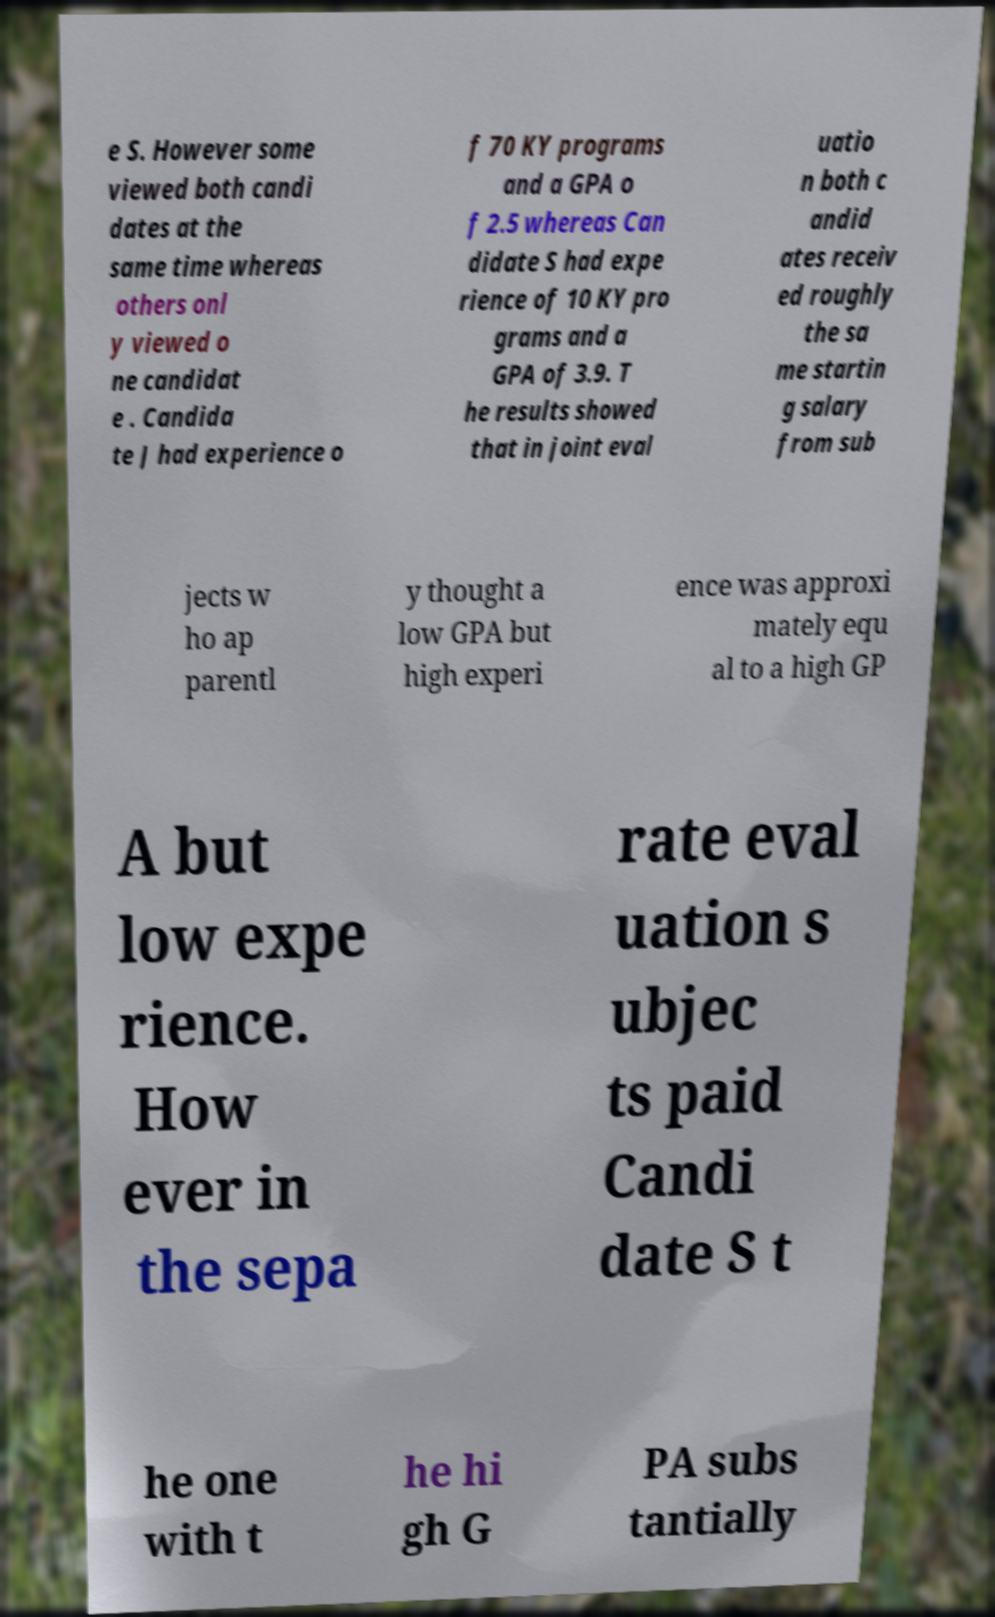Can you accurately transcribe the text from the provided image for me? e S. However some viewed both candi dates at the same time whereas others onl y viewed o ne candidat e . Candida te J had experience o f 70 KY programs and a GPA o f 2.5 whereas Can didate S had expe rience of 10 KY pro grams and a GPA of 3.9. T he results showed that in joint eval uatio n both c andid ates receiv ed roughly the sa me startin g salary from sub jects w ho ap parentl y thought a low GPA but high experi ence was approxi mately equ al to a high GP A but low expe rience. How ever in the sepa rate eval uation s ubjec ts paid Candi date S t he one with t he hi gh G PA subs tantially 